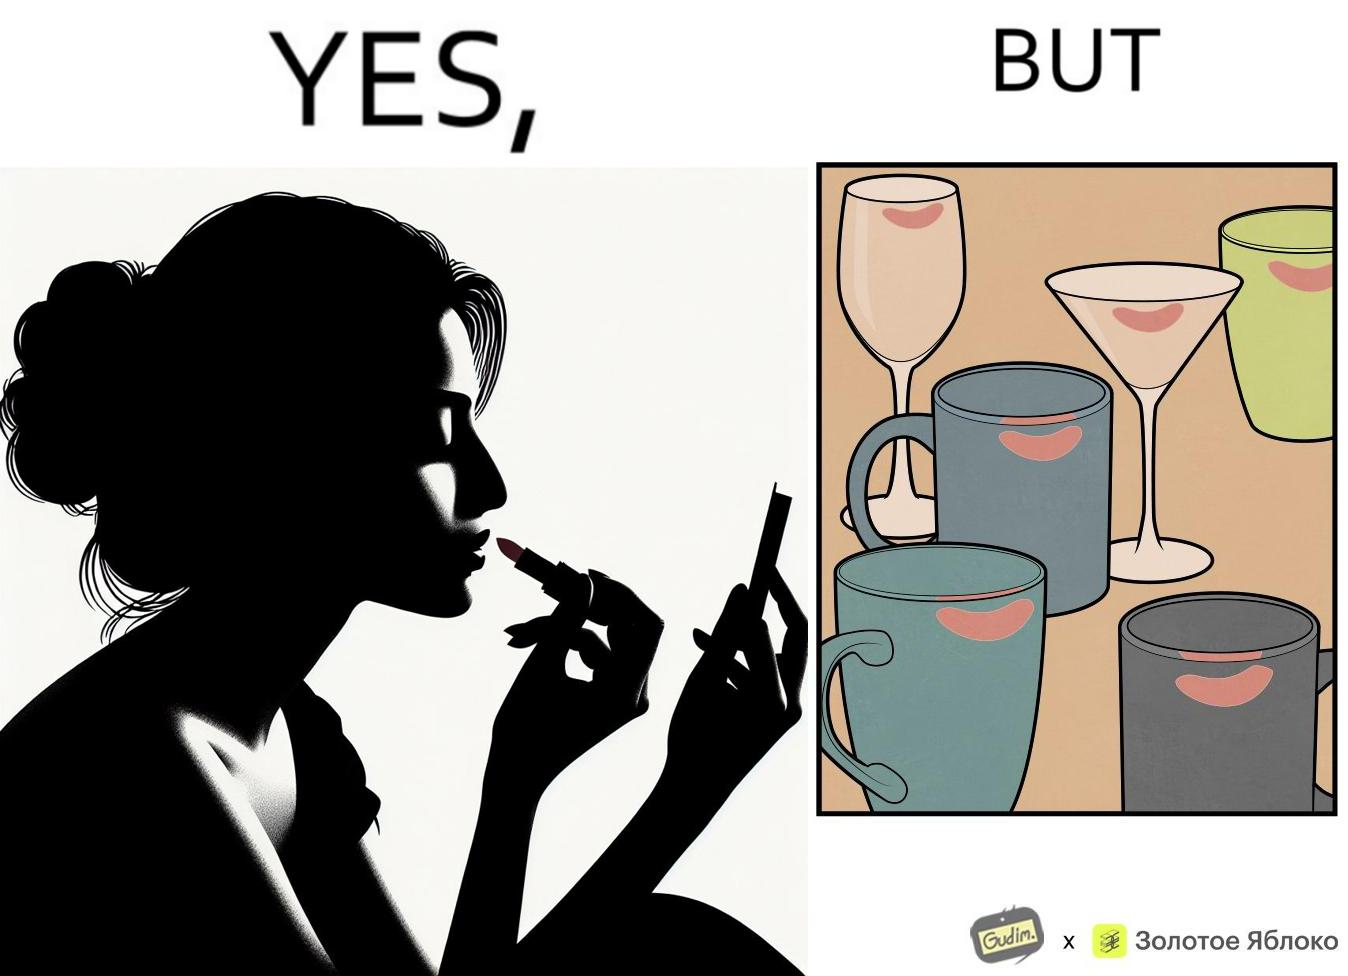Describe what you see in the left and right parts of this image. In the left part of the image: a person applying lipstick, probably a girl or woman In the right part of the image: lipstick stains on various mugs and glasses 